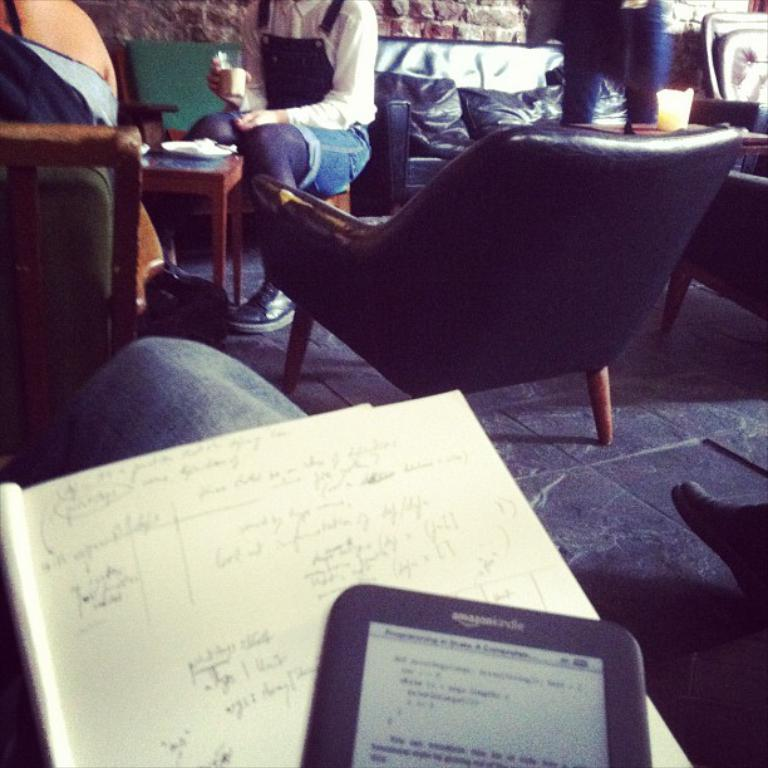What type of furniture is present in the room? There are chairs, sofas, and tables in the room. What can be used for seating in the room? People can sit on the chairs and sofas in the room. What can be found on the chairs, sofas, and tables in the room? There are pillows in the room. Can you see the actor performing on the river in the image? There is no actor or river present in the image; it shows people sitting in a room with furniture. 